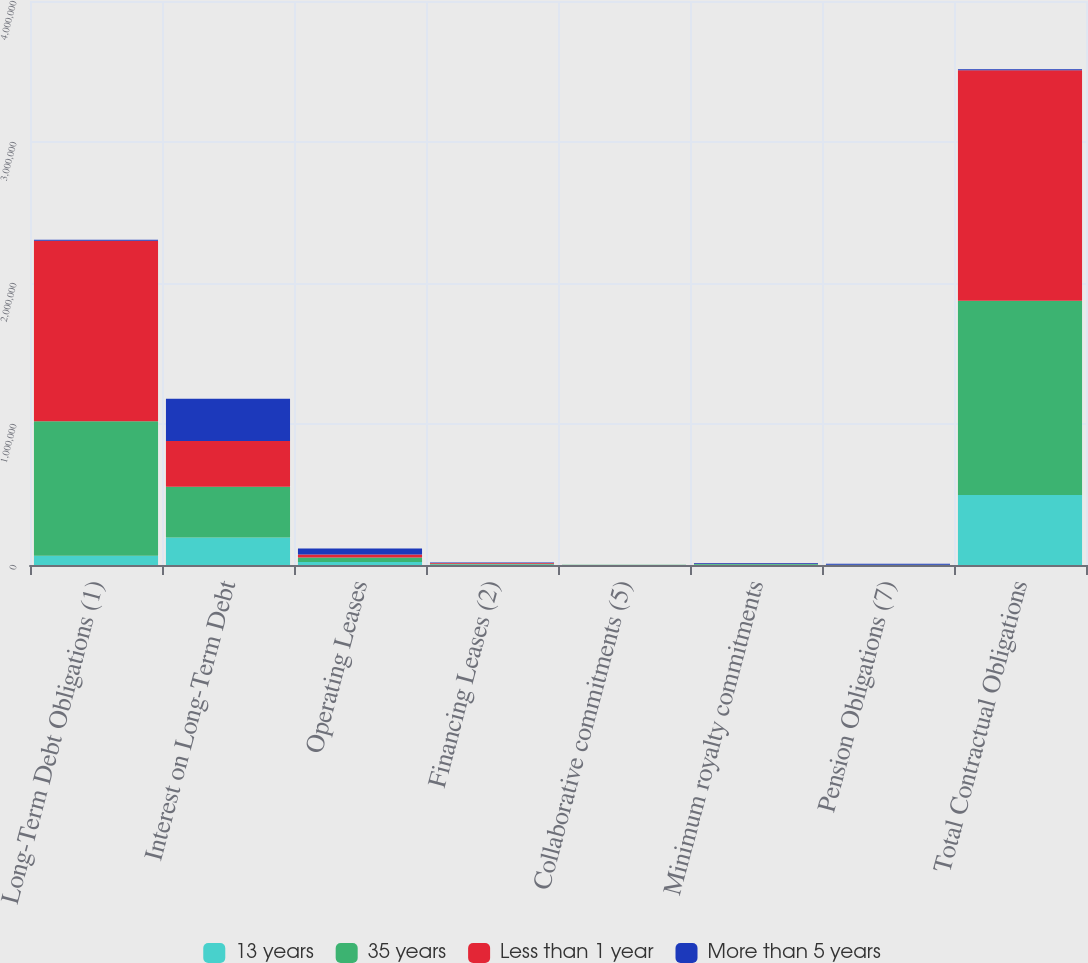Convert chart to OTSL. <chart><loc_0><loc_0><loc_500><loc_500><stacked_bar_chart><ecel><fcel>Long-Term Debt Obligations (1)<fcel>Interest on Long-Term Debt<fcel>Operating Leases<fcel>Financing Leases (2)<fcel>Collaborative commitments (5)<fcel>Minimum royalty commitments<fcel>Pension Obligations (7)<fcel>Total Contractual Obligations<nl><fcel>13 years<fcel>65000<fcel>195574<fcel>21415<fcel>2764<fcel>450<fcel>1985<fcel>347<fcel>496725<nl><fcel>35 years<fcel>955000<fcel>360151<fcel>31459<fcel>5705<fcel>814<fcel>4540<fcel>751<fcel>1.37682e+06<nl><fcel>Less than 1 year<fcel>1.28e+06<fcel>324129<fcel>21474<fcel>6173<fcel>659<fcel>1570<fcel>809<fcel>1.63546e+06<nl><fcel>More than 5 years<fcel>7005<fcel>298465<fcel>42871<fcel>3225<fcel>10<fcel>6020<fcel>7837<fcel>7005<nl></chart> 